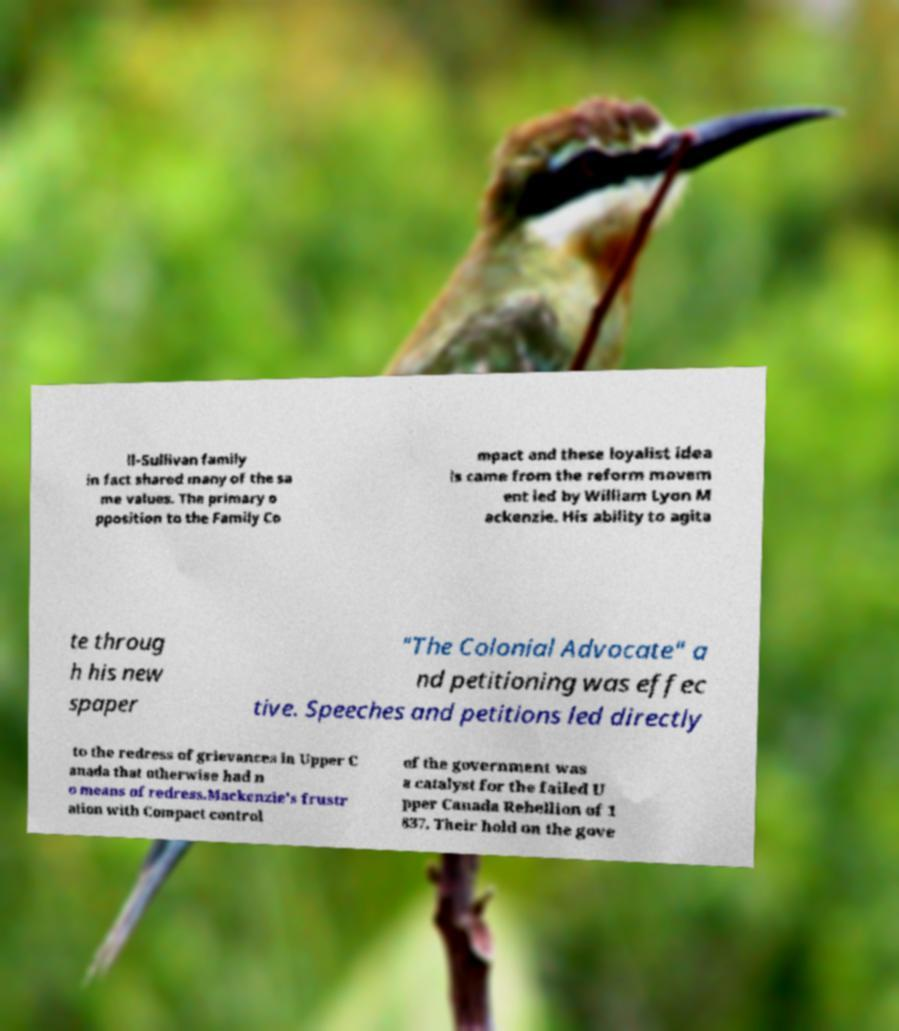Can you read and provide the text displayed in the image?This photo seems to have some interesting text. Can you extract and type it out for me? ll-Sullivan family in fact shared many of the sa me values. The primary o pposition to the Family Co mpact and these loyalist idea ls came from the reform movem ent led by William Lyon M ackenzie. His ability to agita te throug h his new spaper "The Colonial Advocate" a nd petitioning was effec tive. Speeches and petitions led directly to the redress of grievances in Upper C anada that otherwise had n o means of redress.Mackenzie's frustr ation with Compact control of the government was a catalyst for the failed U pper Canada Rebellion of 1 837. Their hold on the gove 